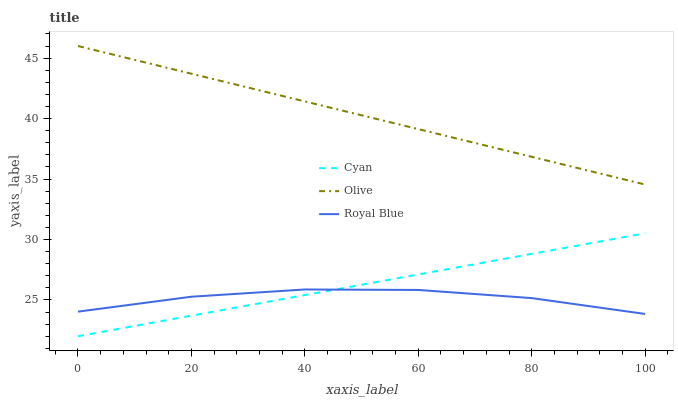Does Royal Blue have the minimum area under the curve?
Answer yes or no. Yes. Does Olive have the maximum area under the curve?
Answer yes or no. Yes. Does Cyan have the minimum area under the curve?
Answer yes or no. No. Does Cyan have the maximum area under the curve?
Answer yes or no. No. Is Olive the smoothest?
Answer yes or no. Yes. Is Royal Blue the roughest?
Answer yes or no. Yes. Is Cyan the smoothest?
Answer yes or no. No. Is Cyan the roughest?
Answer yes or no. No. Does Cyan have the lowest value?
Answer yes or no. Yes. Does Royal Blue have the lowest value?
Answer yes or no. No. Does Olive have the highest value?
Answer yes or no. Yes. Does Cyan have the highest value?
Answer yes or no. No. Is Royal Blue less than Olive?
Answer yes or no. Yes. Is Olive greater than Cyan?
Answer yes or no. Yes. Does Cyan intersect Royal Blue?
Answer yes or no. Yes. Is Cyan less than Royal Blue?
Answer yes or no. No. Is Cyan greater than Royal Blue?
Answer yes or no. No. Does Royal Blue intersect Olive?
Answer yes or no. No. 